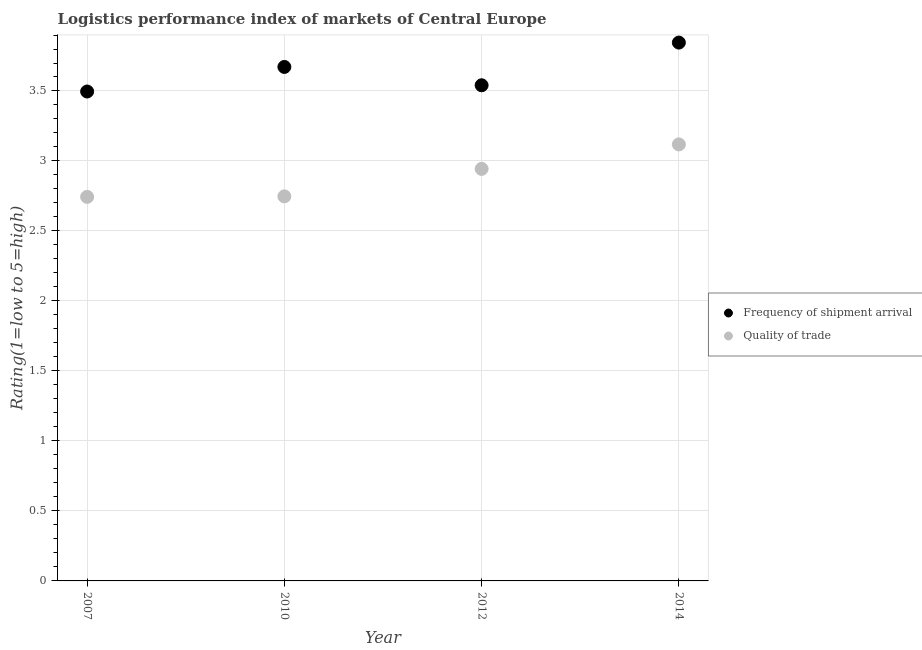What is the lpi quality of trade in 2007?
Make the answer very short. 2.74. Across all years, what is the maximum lpi of frequency of shipment arrival?
Ensure brevity in your answer.  3.85. Across all years, what is the minimum lpi of frequency of shipment arrival?
Provide a short and direct response. 3.5. In which year was the lpi quality of trade maximum?
Ensure brevity in your answer.  2014. In which year was the lpi of frequency of shipment arrival minimum?
Offer a terse response. 2007. What is the total lpi quality of trade in the graph?
Your answer should be very brief. 11.55. What is the difference between the lpi quality of trade in 2007 and that in 2012?
Offer a terse response. -0.2. What is the difference between the lpi of frequency of shipment arrival in 2010 and the lpi quality of trade in 2012?
Your answer should be compact. 0.73. What is the average lpi of frequency of shipment arrival per year?
Your response must be concise. 3.64. In the year 2010, what is the difference between the lpi quality of trade and lpi of frequency of shipment arrival?
Give a very brief answer. -0.92. What is the ratio of the lpi quality of trade in 2012 to that in 2014?
Provide a short and direct response. 0.94. Is the lpi of frequency of shipment arrival in 2007 less than that in 2014?
Make the answer very short. Yes. Is the difference between the lpi quality of trade in 2012 and 2014 greater than the difference between the lpi of frequency of shipment arrival in 2012 and 2014?
Provide a succinct answer. Yes. What is the difference between the highest and the second highest lpi of frequency of shipment arrival?
Give a very brief answer. 0.17. What is the difference between the highest and the lowest lpi quality of trade?
Keep it short and to the point. 0.37. Is the lpi of frequency of shipment arrival strictly greater than the lpi quality of trade over the years?
Keep it short and to the point. Yes. Is the lpi quality of trade strictly less than the lpi of frequency of shipment arrival over the years?
Offer a terse response. Yes. How many dotlines are there?
Offer a very short reply. 2. How many years are there in the graph?
Provide a succinct answer. 4. What is the difference between two consecutive major ticks on the Y-axis?
Offer a very short reply. 0.5. Are the values on the major ticks of Y-axis written in scientific E-notation?
Make the answer very short. No. Does the graph contain any zero values?
Provide a short and direct response. No. Does the graph contain grids?
Your answer should be very brief. Yes. What is the title of the graph?
Provide a short and direct response. Logistics performance index of markets of Central Europe. What is the label or title of the X-axis?
Keep it short and to the point. Year. What is the label or title of the Y-axis?
Offer a very short reply. Rating(1=low to 5=high). What is the Rating(1=low to 5=high) of Frequency of shipment arrival in 2007?
Provide a succinct answer. 3.5. What is the Rating(1=low to 5=high) in Quality of trade in 2007?
Keep it short and to the point. 2.74. What is the Rating(1=low to 5=high) in Frequency of shipment arrival in 2010?
Your response must be concise. 3.67. What is the Rating(1=low to 5=high) of Quality of trade in 2010?
Provide a short and direct response. 2.75. What is the Rating(1=low to 5=high) of Frequency of shipment arrival in 2012?
Your answer should be compact. 3.54. What is the Rating(1=low to 5=high) of Quality of trade in 2012?
Provide a short and direct response. 2.94. What is the Rating(1=low to 5=high) of Frequency of shipment arrival in 2014?
Provide a succinct answer. 3.85. What is the Rating(1=low to 5=high) in Quality of trade in 2014?
Your response must be concise. 3.12. Across all years, what is the maximum Rating(1=low to 5=high) of Frequency of shipment arrival?
Your response must be concise. 3.85. Across all years, what is the maximum Rating(1=low to 5=high) of Quality of trade?
Provide a short and direct response. 3.12. Across all years, what is the minimum Rating(1=low to 5=high) of Frequency of shipment arrival?
Provide a short and direct response. 3.5. Across all years, what is the minimum Rating(1=low to 5=high) in Quality of trade?
Ensure brevity in your answer.  2.74. What is the total Rating(1=low to 5=high) of Frequency of shipment arrival in the graph?
Your answer should be compact. 14.55. What is the total Rating(1=low to 5=high) in Quality of trade in the graph?
Keep it short and to the point. 11.55. What is the difference between the Rating(1=low to 5=high) of Frequency of shipment arrival in 2007 and that in 2010?
Provide a short and direct response. -0.18. What is the difference between the Rating(1=low to 5=high) in Quality of trade in 2007 and that in 2010?
Offer a very short reply. -0. What is the difference between the Rating(1=low to 5=high) of Frequency of shipment arrival in 2007 and that in 2012?
Offer a terse response. -0.04. What is the difference between the Rating(1=low to 5=high) in Quality of trade in 2007 and that in 2012?
Your answer should be very brief. -0.2. What is the difference between the Rating(1=low to 5=high) of Frequency of shipment arrival in 2007 and that in 2014?
Your answer should be very brief. -0.35. What is the difference between the Rating(1=low to 5=high) in Quality of trade in 2007 and that in 2014?
Keep it short and to the point. -0.37. What is the difference between the Rating(1=low to 5=high) in Frequency of shipment arrival in 2010 and that in 2012?
Your answer should be compact. 0.13. What is the difference between the Rating(1=low to 5=high) in Quality of trade in 2010 and that in 2012?
Ensure brevity in your answer.  -0.2. What is the difference between the Rating(1=low to 5=high) in Frequency of shipment arrival in 2010 and that in 2014?
Offer a terse response. -0.17. What is the difference between the Rating(1=low to 5=high) in Quality of trade in 2010 and that in 2014?
Provide a succinct answer. -0.37. What is the difference between the Rating(1=low to 5=high) of Frequency of shipment arrival in 2012 and that in 2014?
Give a very brief answer. -0.3. What is the difference between the Rating(1=low to 5=high) of Quality of trade in 2012 and that in 2014?
Provide a succinct answer. -0.17. What is the difference between the Rating(1=low to 5=high) in Frequency of shipment arrival in 2007 and the Rating(1=low to 5=high) in Quality of trade in 2010?
Provide a succinct answer. 0.75. What is the difference between the Rating(1=low to 5=high) of Frequency of shipment arrival in 2007 and the Rating(1=low to 5=high) of Quality of trade in 2012?
Your answer should be compact. 0.55. What is the difference between the Rating(1=low to 5=high) of Frequency of shipment arrival in 2007 and the Rating(1=low to 5=high) of Quality of trade in 2014?
Your response must be concise. 0.38. What is the difference between the Rating(1=low to 5=high) of Frequency of shipment arrival in 2010 and the Rating(1=low to 5=high) of Quality of trade in 2012?
Ensure brevity in your answer.  0.73. What is the difference between the Rating(1=low to 5=high) in Frequency of shipment arrival in 2010 and the Rating(1=low to 5=high) in Quality of trade in 2014?
Give a very brief answer. 0.55. What is the difference between the Rating(1=low to 5=high) in Frequency of shipment arrival in 2012 and the Rating(1=low to 5=high) in Quality of trade in 2014?
Provide a short and direct response. 0.42. What is the average Rating(1=low to 5=high) of Frequency of shipment arrival per year?
Provide a succinct answer. 3.64. What is the average Rating(1=low to 5=high) in Quality of trade per year?
Offer a very short reply. 2.89. In the year 2007, what is the difference between the Rating(1=low to 5=high) in Frequency of shipment arrival and Rating(1=low to 5=high) in Quality of trade?
Keep it short and to the point. 0.75. In the year 2010, what is the difference between the Rating(1=low to 5=high) in Frequency of shipment arrival and Rating(1=low to 5=high) in Quality of trade?
Your answer should be very brief. 0.92. In the year 2012, what is the difference between the Rating(1=low to 5=high) of Frequency of shipment arrival and Rating(1=low to 5=high) of Quality of trade?
Provide a succinct answer. 0.6. In the year 2014, what is the difference between the Rating(1=low to 5=high) of Frequency of shipment arrival and Rating(1=low to 5=high) of Quality of trade?
Your answer should be very brief. 0.73. What is the ratio of the Rating(1=low to 5=high) of Frequency of shipment arrival in 2007 to that in 2010?
Your response must be concise. 0.95. What is the ratio of the Rating(1=low to 5=high) of Frequency of shipment arrival in 2007 to that in 2012?
Offer a very short reply. 0.99. What is the ratio of the Rating(1=low to 5=high) in Quality of trade in 2007 to that in 2012?
Keep it short and to the point. 0.93. What is the ratio of the Rating(1=low to 5=high) of Quality of trade in 2007 to that in 2014?
Your answer should be very brief. 0.88. What is the ratio of the Rating(1=low to 5=high) in Frequency of shipment arrival in 2010 to that in 2012?
Offer a very short reply. 1.04. What is the ratio of the Rating(1=low to 5=high) in Quality of trade in 2010 to that in 2012?
Your answer should be compact. 0.93. What is the ratio of the Rating(1=low to 5=high) in Frequency of shipment arrival in 2010 to that in 2014?
Your answer should be compact. 0.95. What is the ratio of the Rating(1=low to 5=high) of Quality of trade in 2010 to that in 2014?
Your answer should be very brief. 0.88. What is the ratio of the Rating(1=low to 5=high) of Frequency of shipment arrival in 2012 to that in 2014?
Provide a short and direct response. 0.92. What is the ratio of the Rating(1=low to 5=high) of Quality of trade in 2012 to that in 2014?
Offer a terse response. 0.94. What is the difference between the highest and the second highest Rating(1=low to 5=high) of Frequency of shipment arrival?
Offer a terse response. 0.17. What is the difference between the highest and the second highest Rating(1=low to 5=high) in Quality of trade?
Provide a short and direct response. 0.17. What is the difference between the highest and the lowest Rating(1=low to 5=high) of Frequency of shipment arrival?
Your answer should be very brief. 0.35. What is the difference between the highest and the lowest Rating(1=low to 5=high) in Quality of trade?
Ensure brevity in your answer.  0.37. 